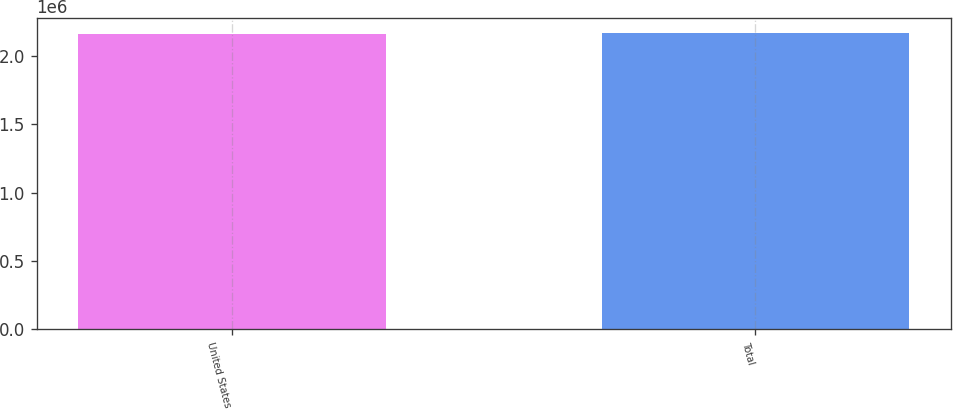Convert chart to OTSL. <chart><loc_0><loc_0><loc_500><loc_500><bar_chart><fcel>United States<fcel>Total<nl><fcel>2.1623e+06<fcel>2.17349e+06<nl></chart> 